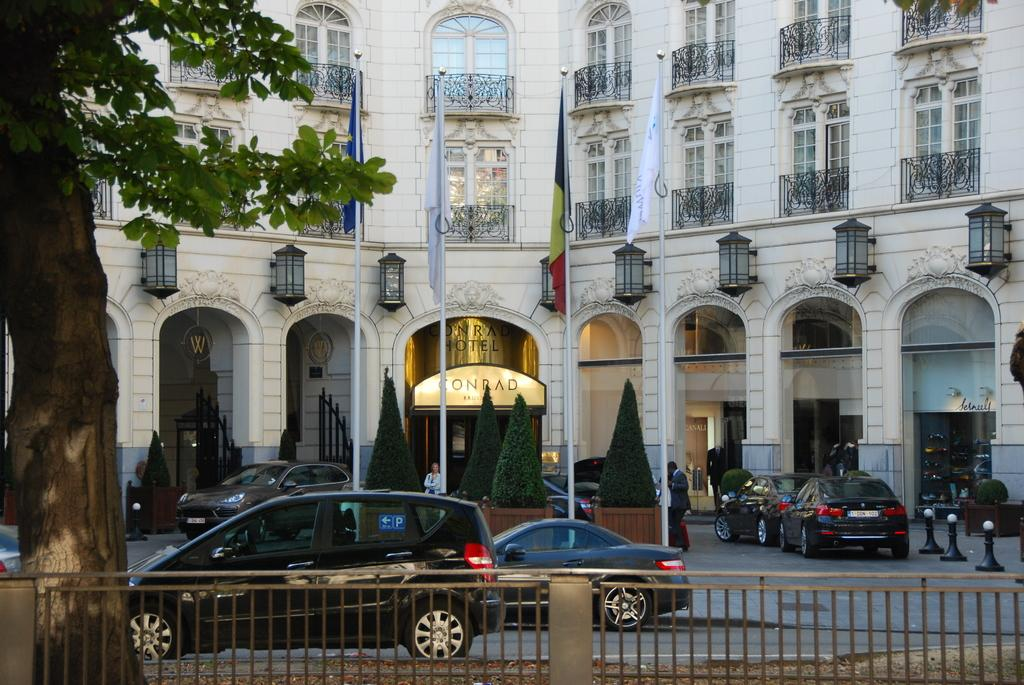What can be seen running through the image? There is a rail in the image. What is happening on the road in the image? There are vehicles on the road in the image. What decorative elements are visible in the image? There are flags visible in the image. What can be seen in the distance in the image? There are trees and a building in the background of the image. What type of finger can be seen holding the rail in the image? There are no fingers visible in the image; it only shows a rail, vehicles on the road, flags, trees, and a building in the background. What part of the building is used as a cushion in the image? There is no cushion or any part of the building being used as a cushion in the image. 